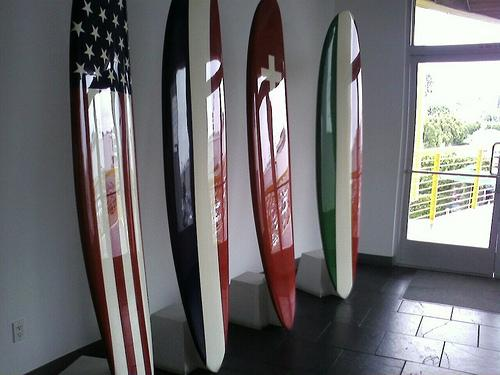What theme seems to have inspired the painting of the surfboards?

Choices:
A) countries
B) sports
C) cars
D) superheroes countries 